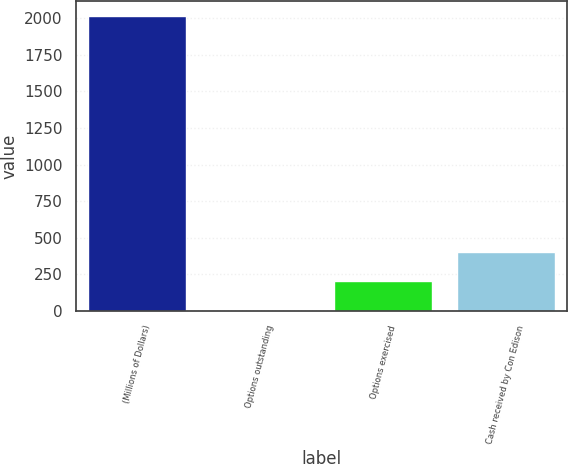Convert chart to OTSL. <chart><loc_0><loc_0><loc_500><loc_500><bar_chart><fcel>(Millions of Dollars)<fcel>Options outstanding<fcel>Options exercised<fcel>Cash received by Con Edison<nl><fcel>2015<fcel>1<fcel>202.4<fcel>403.8<nl></chart> 